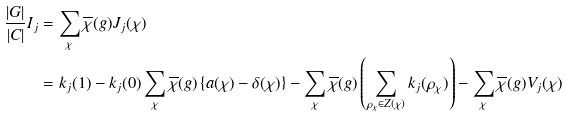Convert formula to latex. <formula><loc_0><loc_0><loc_500><loc_500>\frac { | G | } { | C | } I _ { j } & = \sum _ { \chi } \overline { \chi } ( g ) J _ { j } ( \chi ) \\ & = k _ { j } ( 1 ) - k _ { j } ( 0 ) \sum _ { \chi } \overline { \chi } ( g ) \left \{ a ( \chi ) - \delta ( \chi ) \right \} - \sum _ { \chi } \overline { \chi } ( g ) \left ( \sum _ { \rho _ { \chi } \in Z ( \chi ) } k _ { j } ( \rho _ { \chi } ) \right ) - \sum _ { \chi } \overline { \chi } ( g ) V _ { j } ( \chi )</formula> 